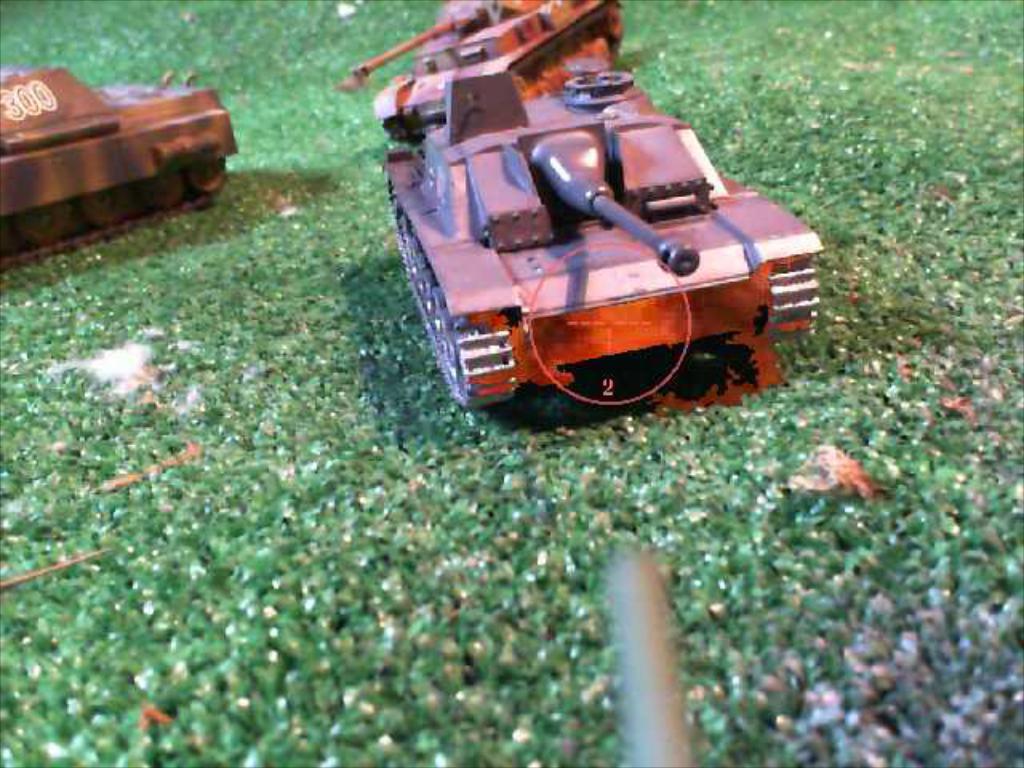Could you give a brief overview of what you see in this image? In the center of the image we can see churchill tanks. At the bottom there is grass. 